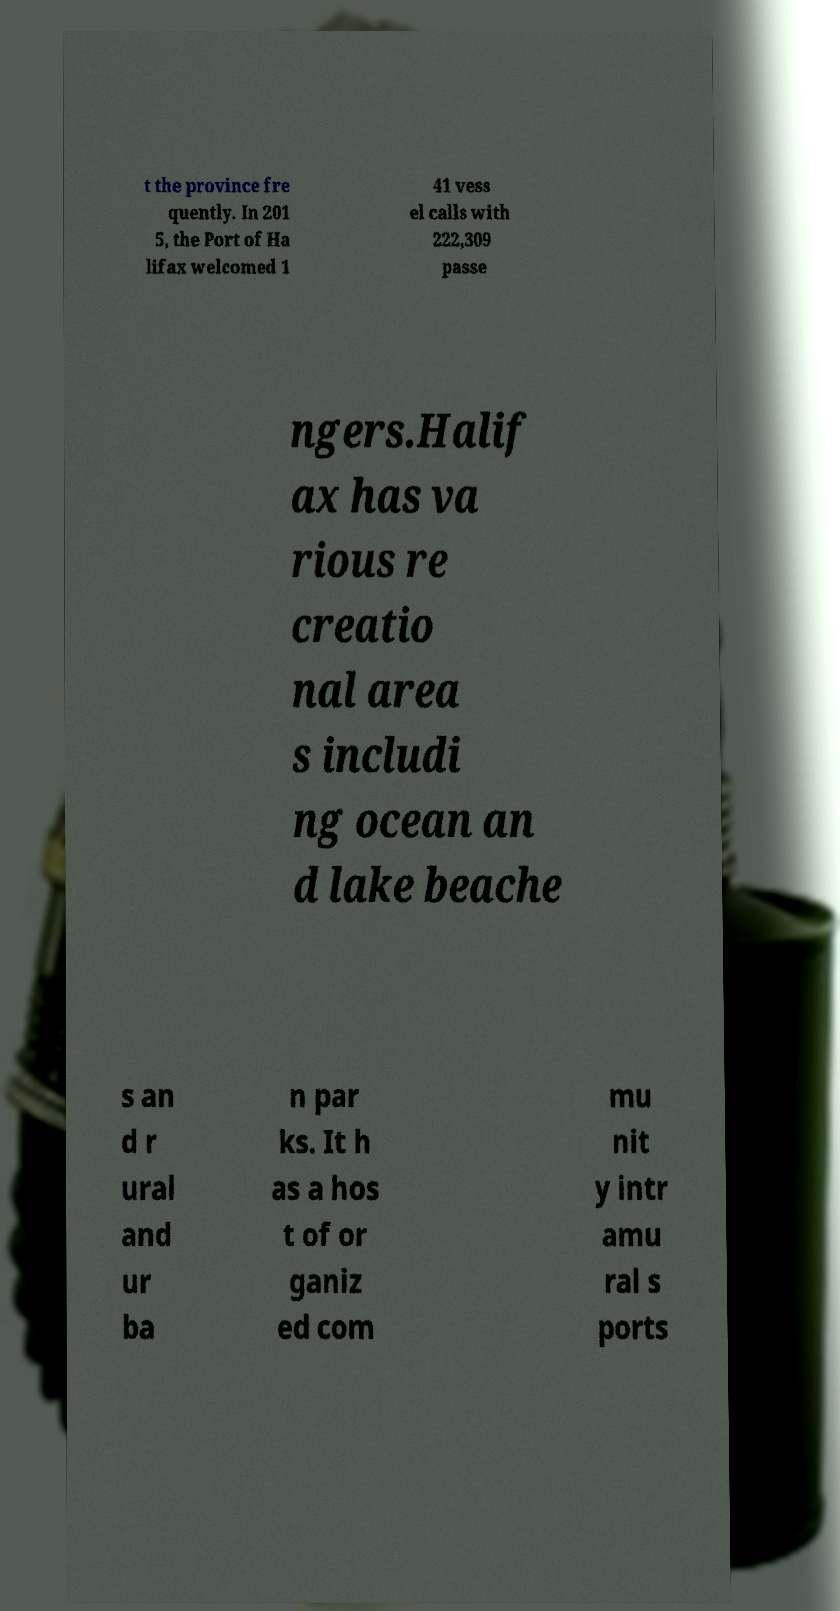I need the written content from this picture converted into text. Can you do that? t the province fre quently. In 201 5, the Port of Ha lifax welcomed 1 41 vess el calls with 222,309 passe ngers.Halif ax has va rious re creatio nal area s includi ng ocean an d lake beache s an d r ural and ur ba n par ks. It h as a hos t of or ganiz ed com mu nit y intr amu ral s ports 